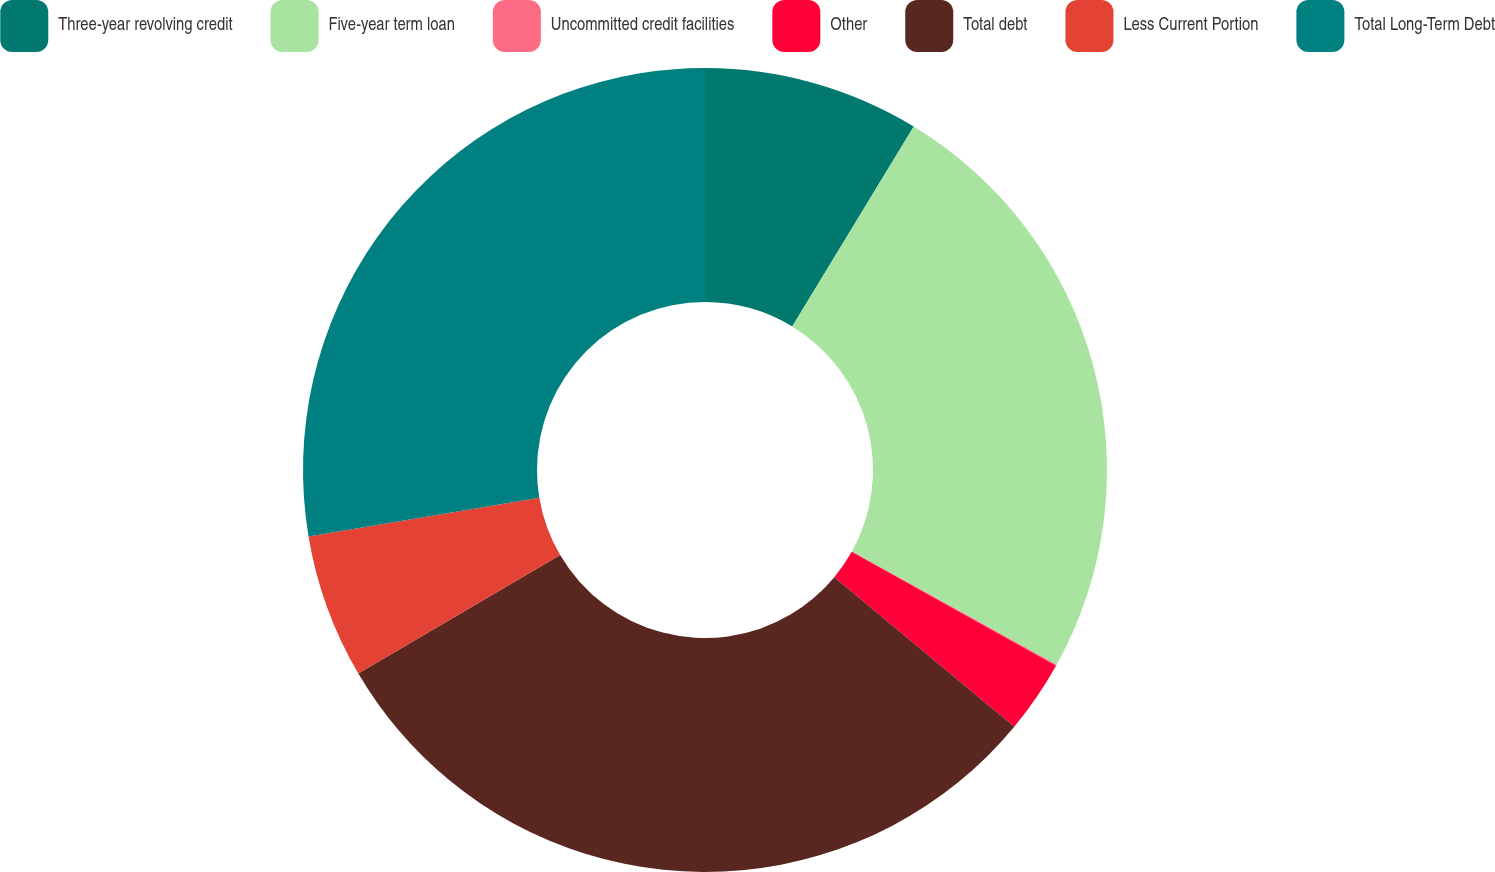Convert chart to OTSL. <chart><loc_0><loc_0><loc_500><loc_500><pie_chart><fcel>Three-year revolving credit<fcel>Five-year term loan<fcel>Uncommitted credit facilities<fcel>Other<fcel>Total debt<fcel>Less Current Portion<fcel>Total Long-Term Debt<nl><fcel>8.69%<fcel>24.36%<fcel>0.05%<fcel>2.93%<fcel>30.52%<fcel>5.81%<fcel>27.64%<nl></chart> 